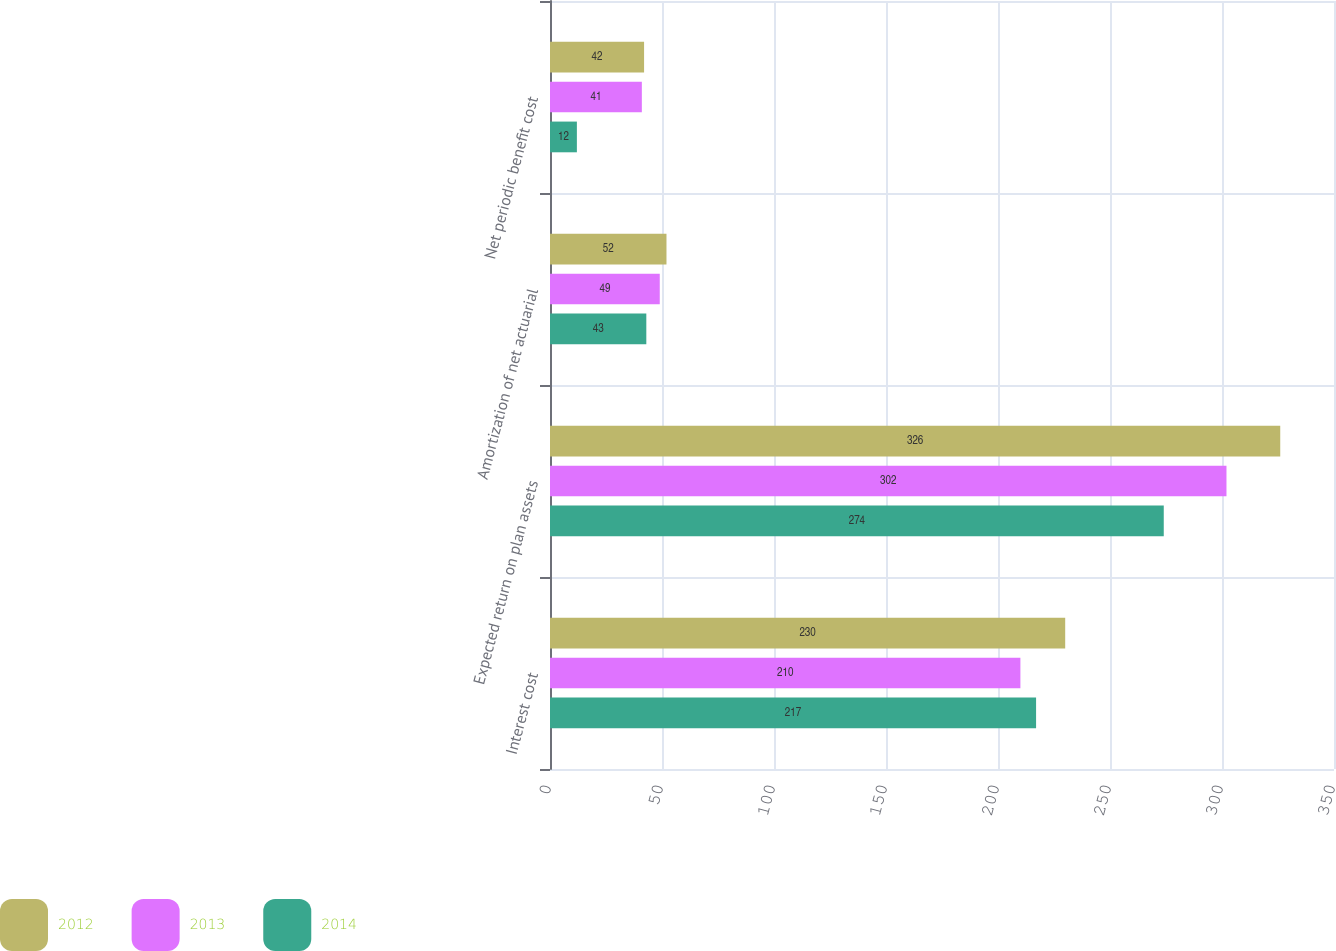Convert chart to OTSL. <chart><loc_0><loc_0><loc_500><loc_500><stacked_bar_chart><ecel><fcel>Interest cost<fcel>Expected return on plan assets<fcel>Amortization of net actuarial<fcel>Net periodic benefit cost<nl><fcel>2012<fcel>230<fcel>326<fcel>52<fcel>42<nl><fcel>2013<fcel>210<fcel>302<fcel>49<fcel>41<nl><fcel>2014<fcel>217<fcel>274<fcel>43<fcel>12<nl></chart> 